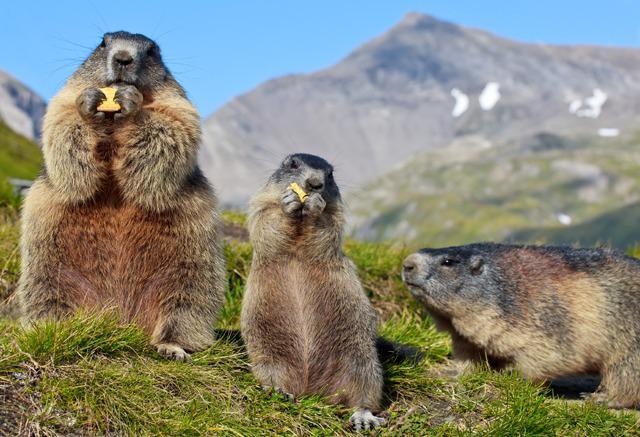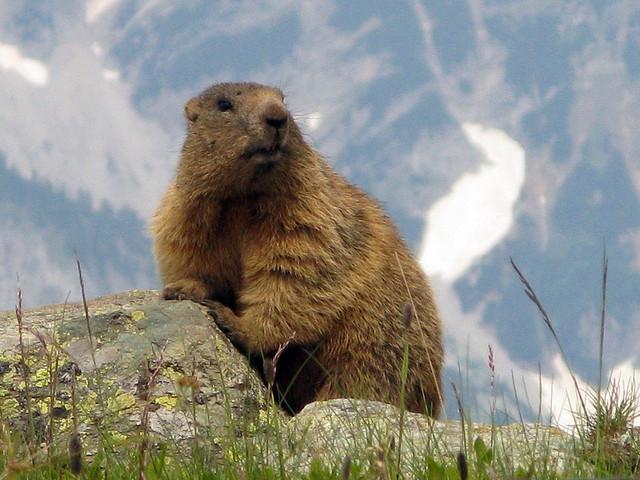The first image is the image on the left, the second image is the image on the right. Assess this claim about the two images: "There is more than one animal in at least one image.". Correct or not? Answer yes or no. Yes. 